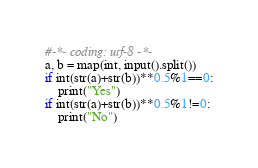Convert code to text. <code><loc_0><loc_0><loc_500><loc_500><_Python_>#-*- coding: utf-8 -*-
a, b = map(int, input().split())
if int(str(a)+str(b))**0.5%1==0:
    print("Yes")
if int(str(a)+str(b))**0.5%1!=0:
    print("No")</code> 